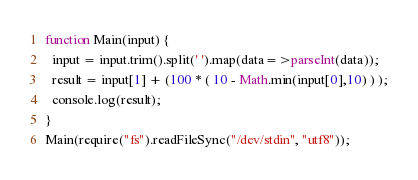Convert code to text. <code><loc_0><loc_0><loc_500><loc_500><_JavaScript_>function Main(input) {
  input = input.trim().split(' ').map(data=>parseInt(data));
  result = input[1] + (100 * ( 10 - Math.min(input[0],10) ) );
  console.log(result);
}
Main(require("fs").readFileSync("/dev/stdin", "utf8"));</code> 